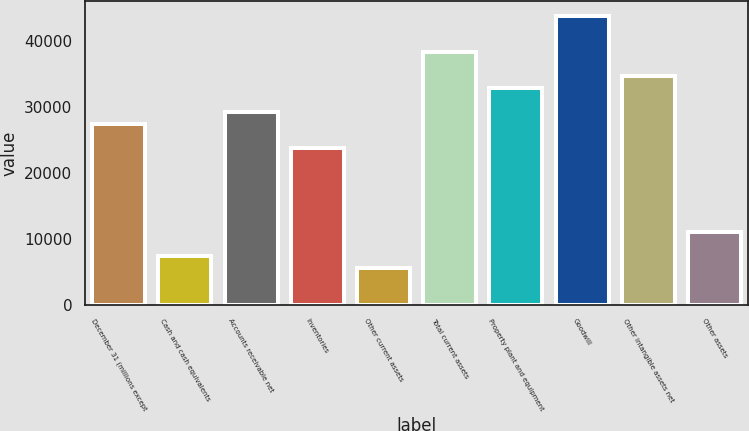Convert chart to OTSL. <chart><loc_0><loc_0><loc_500><loc_500><bar_chart><fcel>December 31 (millions except<fcel>Cash and cash equivalents<fcel>Accounts receivable net<fcel>Inventories<fcel>Other current assets<fcel>Total current assets<fcel>Property plant and equipment<fcel>Goodwill<fcel>Other intangible assets net<fcel>Other assets<nl><fcel>27460.4<fcel>7373.96<fcel>29286.4<fcel>23808.3<fcel>5547.92<fcel>38416.6<fcel>32938.5<fcel>43894.8<fcel>34764.6<fcel>11026<nl></chart> 